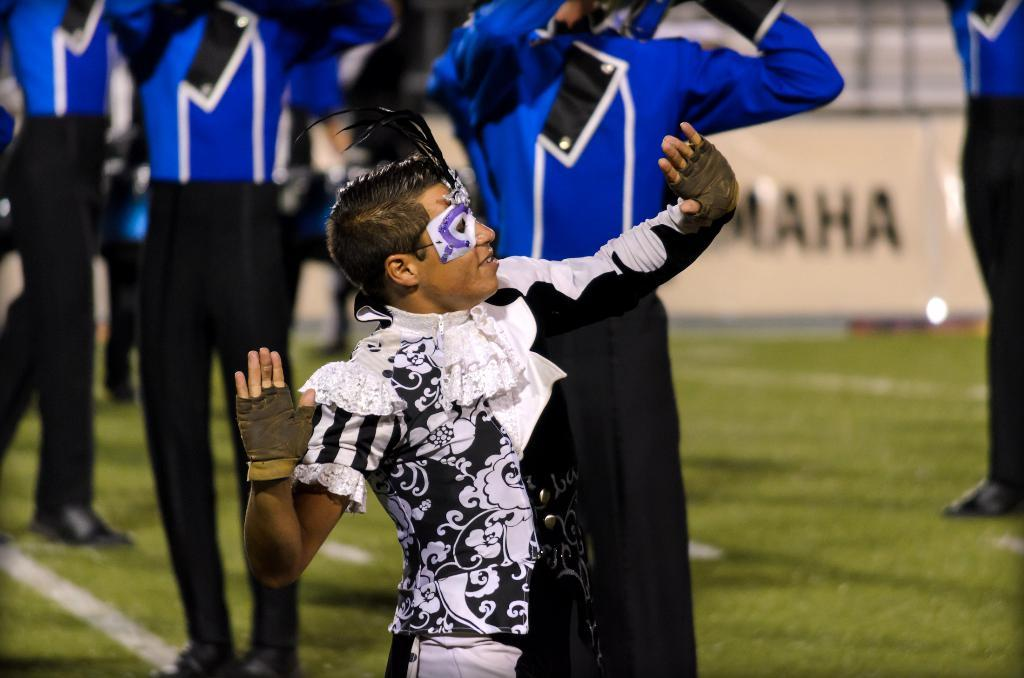<image>
Summarize the visual content of the image. Omaha is a field sponsor during football season. 